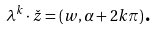Convert formula to latex. <formula><loc_0><loc_0><loc_500><loc_500>\lambda ^ { k } \cdot \check { z } = ( w , \alpha + 2 k \pi ) \text {.}</formula> 